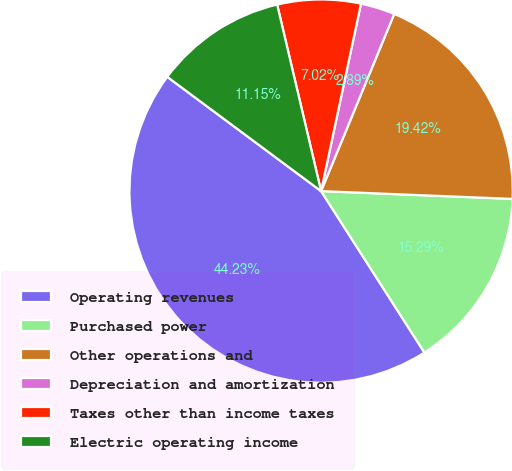Convert chart. <chart><loc_0><loc_0><loc_500><loc_500><pie_chart><fcel>Operating revenues<fcel>Purchased power<fcel>Other operations and<fcel>Depreciation and amortization<fcel>Taxes other than income taxes<fcel>Electric operating income<nl><fcel>44.23%<fcel>15.29%<fcel>19.42%<fcel>2.89%<fcel>7.02%<fcel>11.15%<nl></chart> 